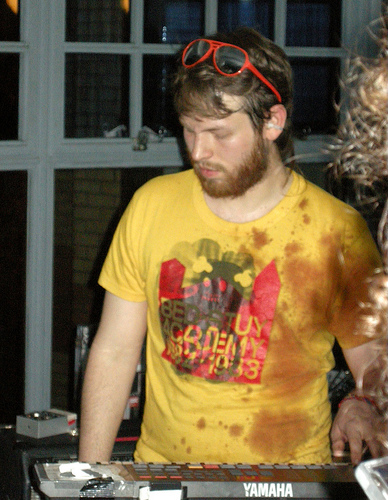<image>
Can you confirm if the man is on the keyboard? Yes. Looking at the image, I can see the man is positioned on top of the keyboard, with the keyboard providing support. 